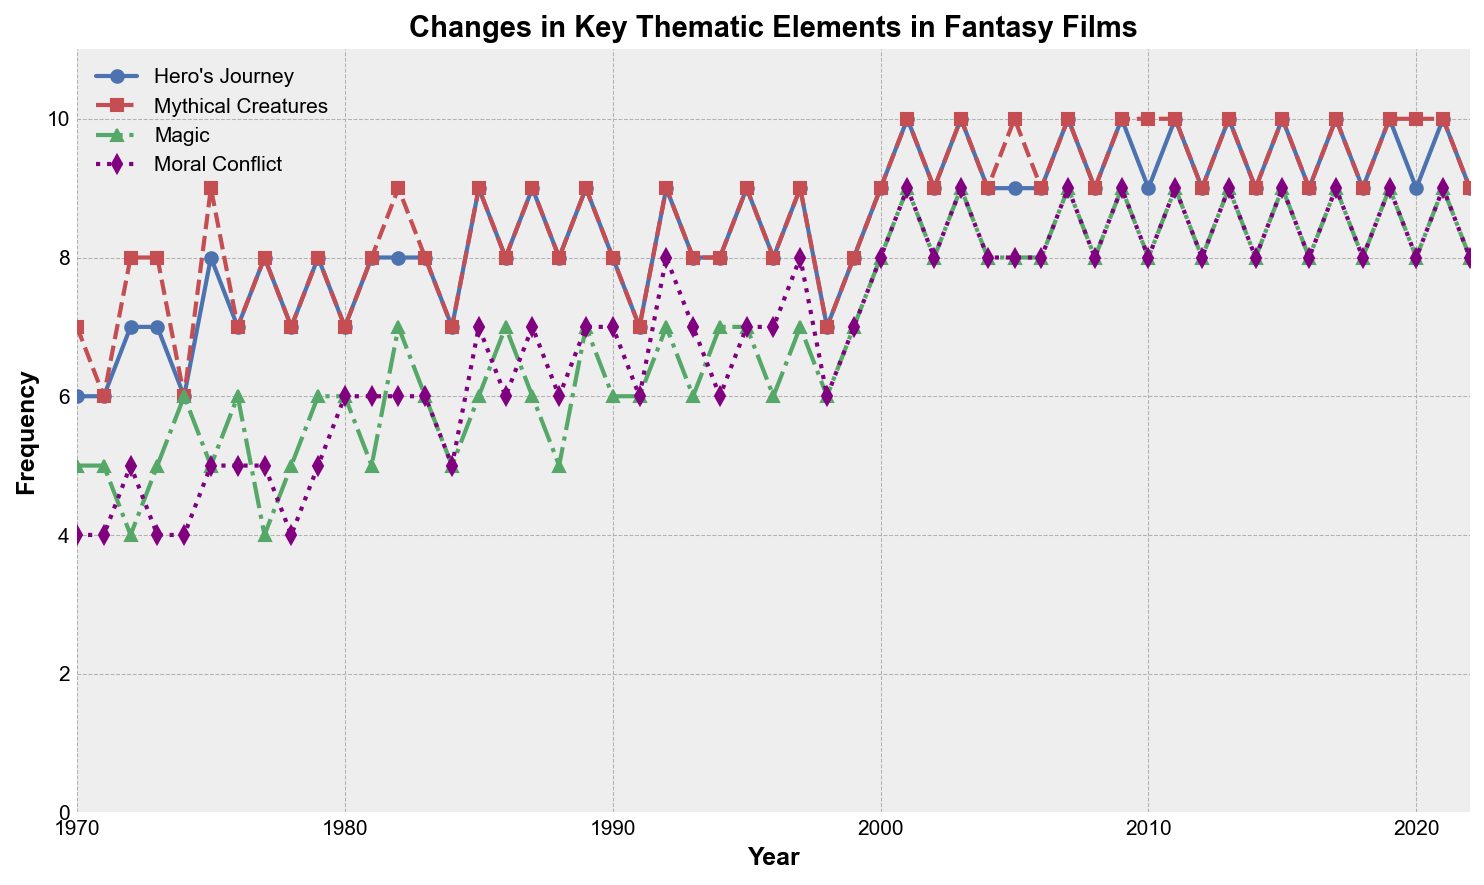What is the trend of frequency in the Hero's Journey element from 1980 to 2000? Examine the blue line for Hero's Journey from the years 1980 to 2000. Observe how it fluctuates, rising and falling. The trend shows an overall increase from 7 in 1980 to 9 in 2000.
Answer: Rising trend Which thematic element saw the highest increase in frequency from pre-1980 to the post-2000 era? Compare the starting values of frequency for each thematic element around 1970-1979 with their values around 2000-2022. The Hero's Journey and Magic elements have the highest increases, but Magic sees a sharper rise from around 5-6 to 9.
Answer: Magic How does the trend of the Mythical Creatures element compare to that of Magic from 1990 to 2000? Examine the red line (Mythical Creatures) and the green line (Magic) between the years 1990 and 2000. Mythical Creatures remains consistently high at 8-9 throughout, while Magic increases more significantly from 6-7 to 8-9.
Answer: Magic has a steeper increase By how much did the frequency of Moral Conflict change from 1985 to 2005? Look at the purple line for Moral Conflict in 1985 and note the value (7) and compare it to 2005 (8). The change is 8 - 7 = 1.
Answer: 1 Which thematic element exhibited the most consistent frequency over the entire timeline? Visually inspect each line for the least fluctuation in value. The Mythical Creatures (red line) remains most consistently around 9-10.
Answer: Mythical Creatures What is the median frequency value for the Hero's Journey element between 2000 and 2022? List the values of Hero's Journey from 2000 to 2022 (starting at 9,10,9,10...), sort them, and find the middle value(s). The median of [9, 10, 9, 10, 9, 10...] is 9.
Answer: 9 During which decade did Magic experience the most rapid increase? Scan the green line and note steeper increases over decades. The significant jump is observed around 2000-2010 going from 7 to 9.
Answer: 2000-2010 What was the difference in frequency of Hero's Journey and Mythical Creatures in the year 1985? Examine the plot points for both elements in 1985: Hero's Journey (9) and Mythical Creatures (9). The difference is 9 - 9 = 0.
Answer: 0 In which year was the frequency of moral conflict first higher than 6? Track the purple line of Moral Conflict over years until it exceeds 6. The first occurrence is in 1985.
Answer: 1985 